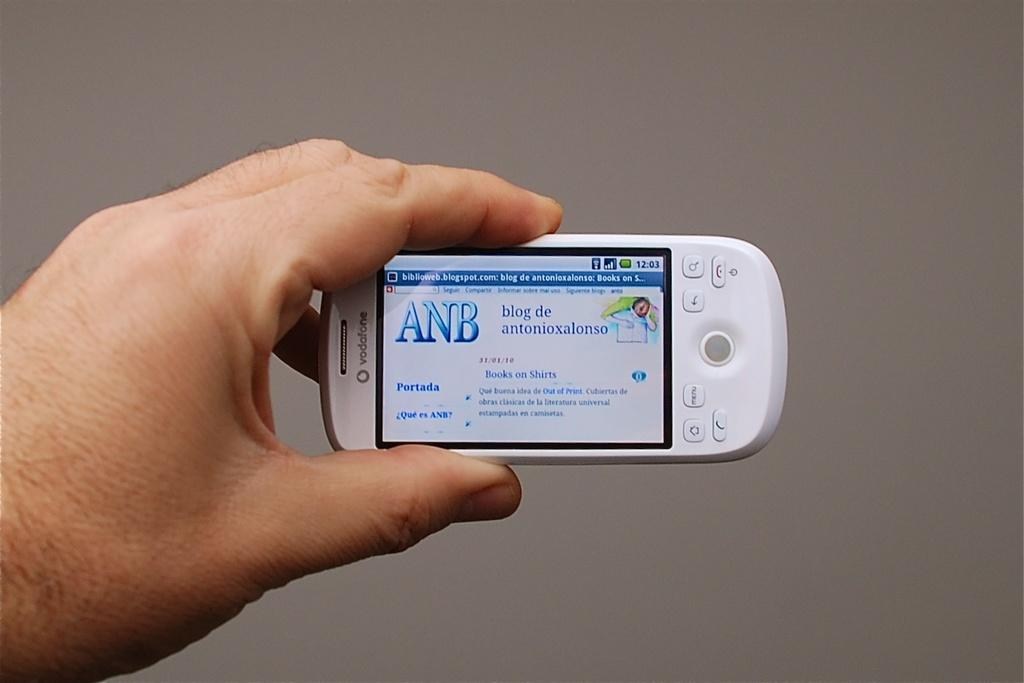Provide a one-sentence caption for the provided image. A hand holding a white cell phone that reads ANB. 